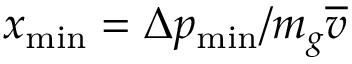<formula> <loc_0><loc_0><loc_500><loc_500>x _ { \min } = \Delta p _ { \min } / m _ { g } \overline { v }</formula> 